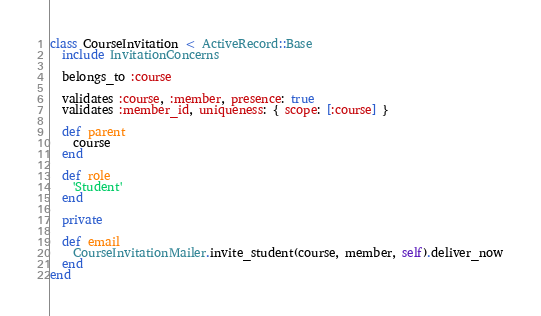Convert code to text. <code><loc_0><loc_0><loc_500><loc_500><_Ruby_>class CourseInvitation < ActiveRecord::Base
  include InvitationConcerns

  belongs_to :course

  validates :course, :member, presence: true
  validates :member_id, uniqueness: { scope: [:course] }

  def parent
    course
  end

  def role
    'Student'
  end

  private

  def email
    CourseInvitationMailer.invite_student(course, member, self).deliver_now
  end
end
</code> 